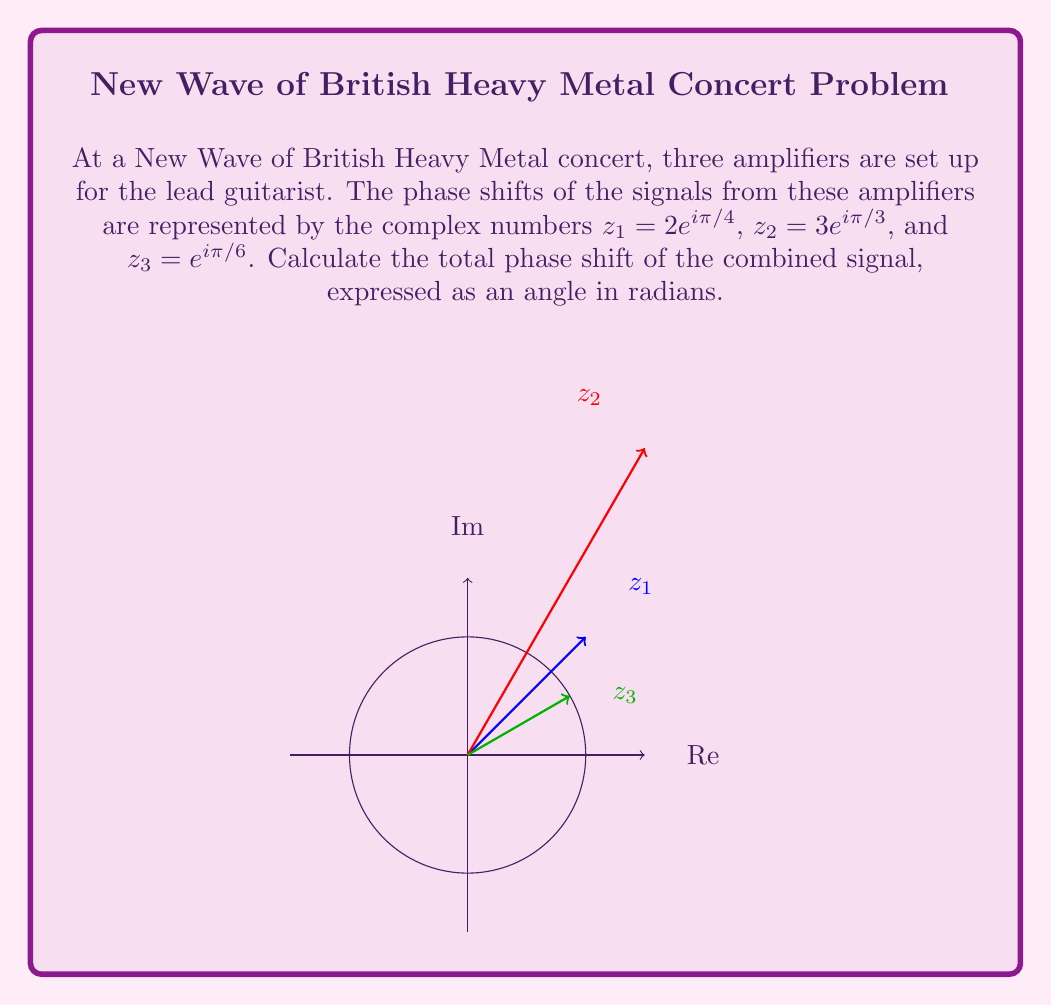Solve this math problem. To find the total phase shift, we need to multiply the complex numbers representing each amplifier's phase shift:

1) $z_{total} = z_1 \cdot z_2 \cdot z_3$

2) $z_{total} = (2e^{i\pi/4}) \cdot (3e^{i\pi/3}) \cdot (e^{i\pi/6})$

3) Using the properties of complex exponentials, we can add the exponents:
   $z_{total} = 2 \cdot 3 \cdot 1 \cdot e^{i(\pi/4 + \pi/3 + \pi/6)}$

4) Simplify:
   $z_{total} = 6e^{i(\pi/4 + \pi/3 + \pi/6)}$

5) Add the fractions in the exponent:
   $z_{total} = 6e^{i(3\pi/12 + 4\pi/12 + 2\pi/12)}$
   $z_{total} = 6e^{i(9\pi/12)}$
   $z_{total} = 6e^{i(3\pi/4)}$

6) The total phase shift is the argument of this complex number, which is the angle in the exponent: $3\pi/4$ radians.
Answer: $\frac{3\pi}{4}$ radians 